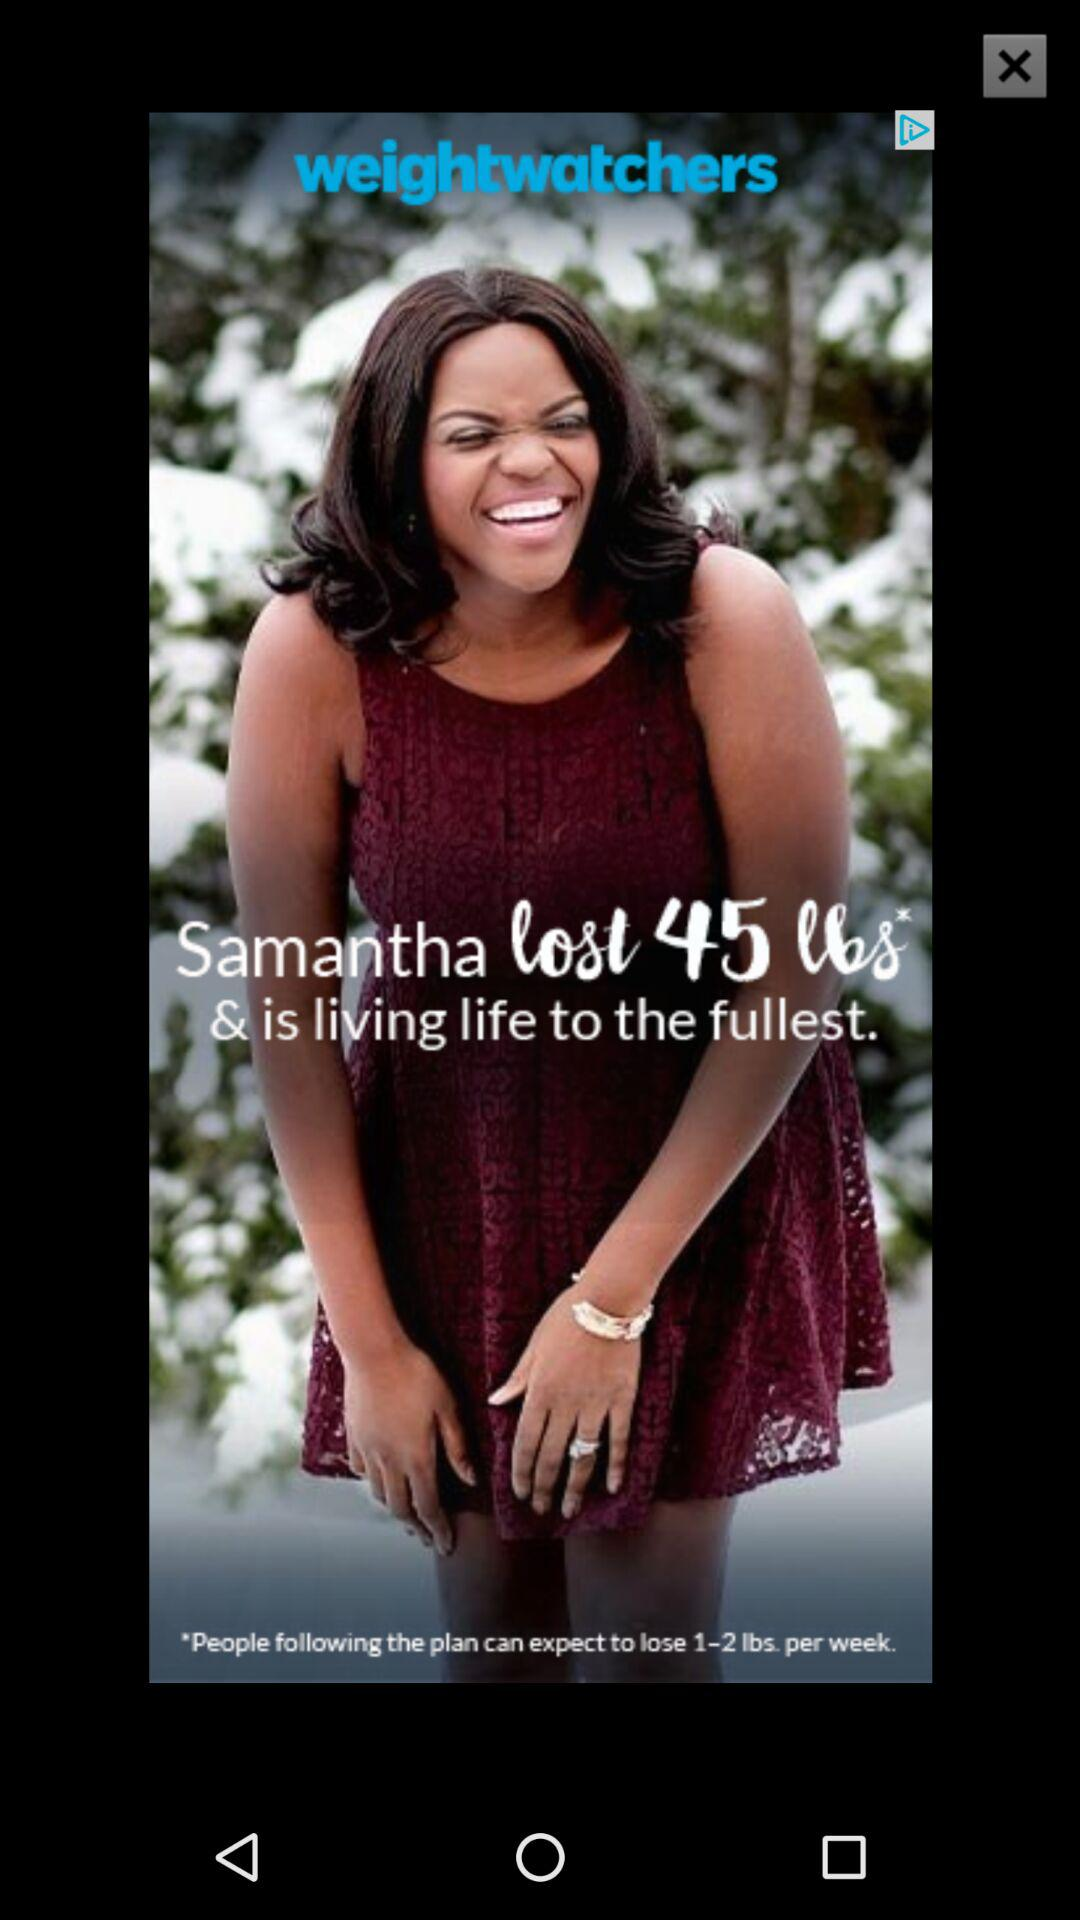How much weight did Samantha lose? Samantha lost 45 lbs. 